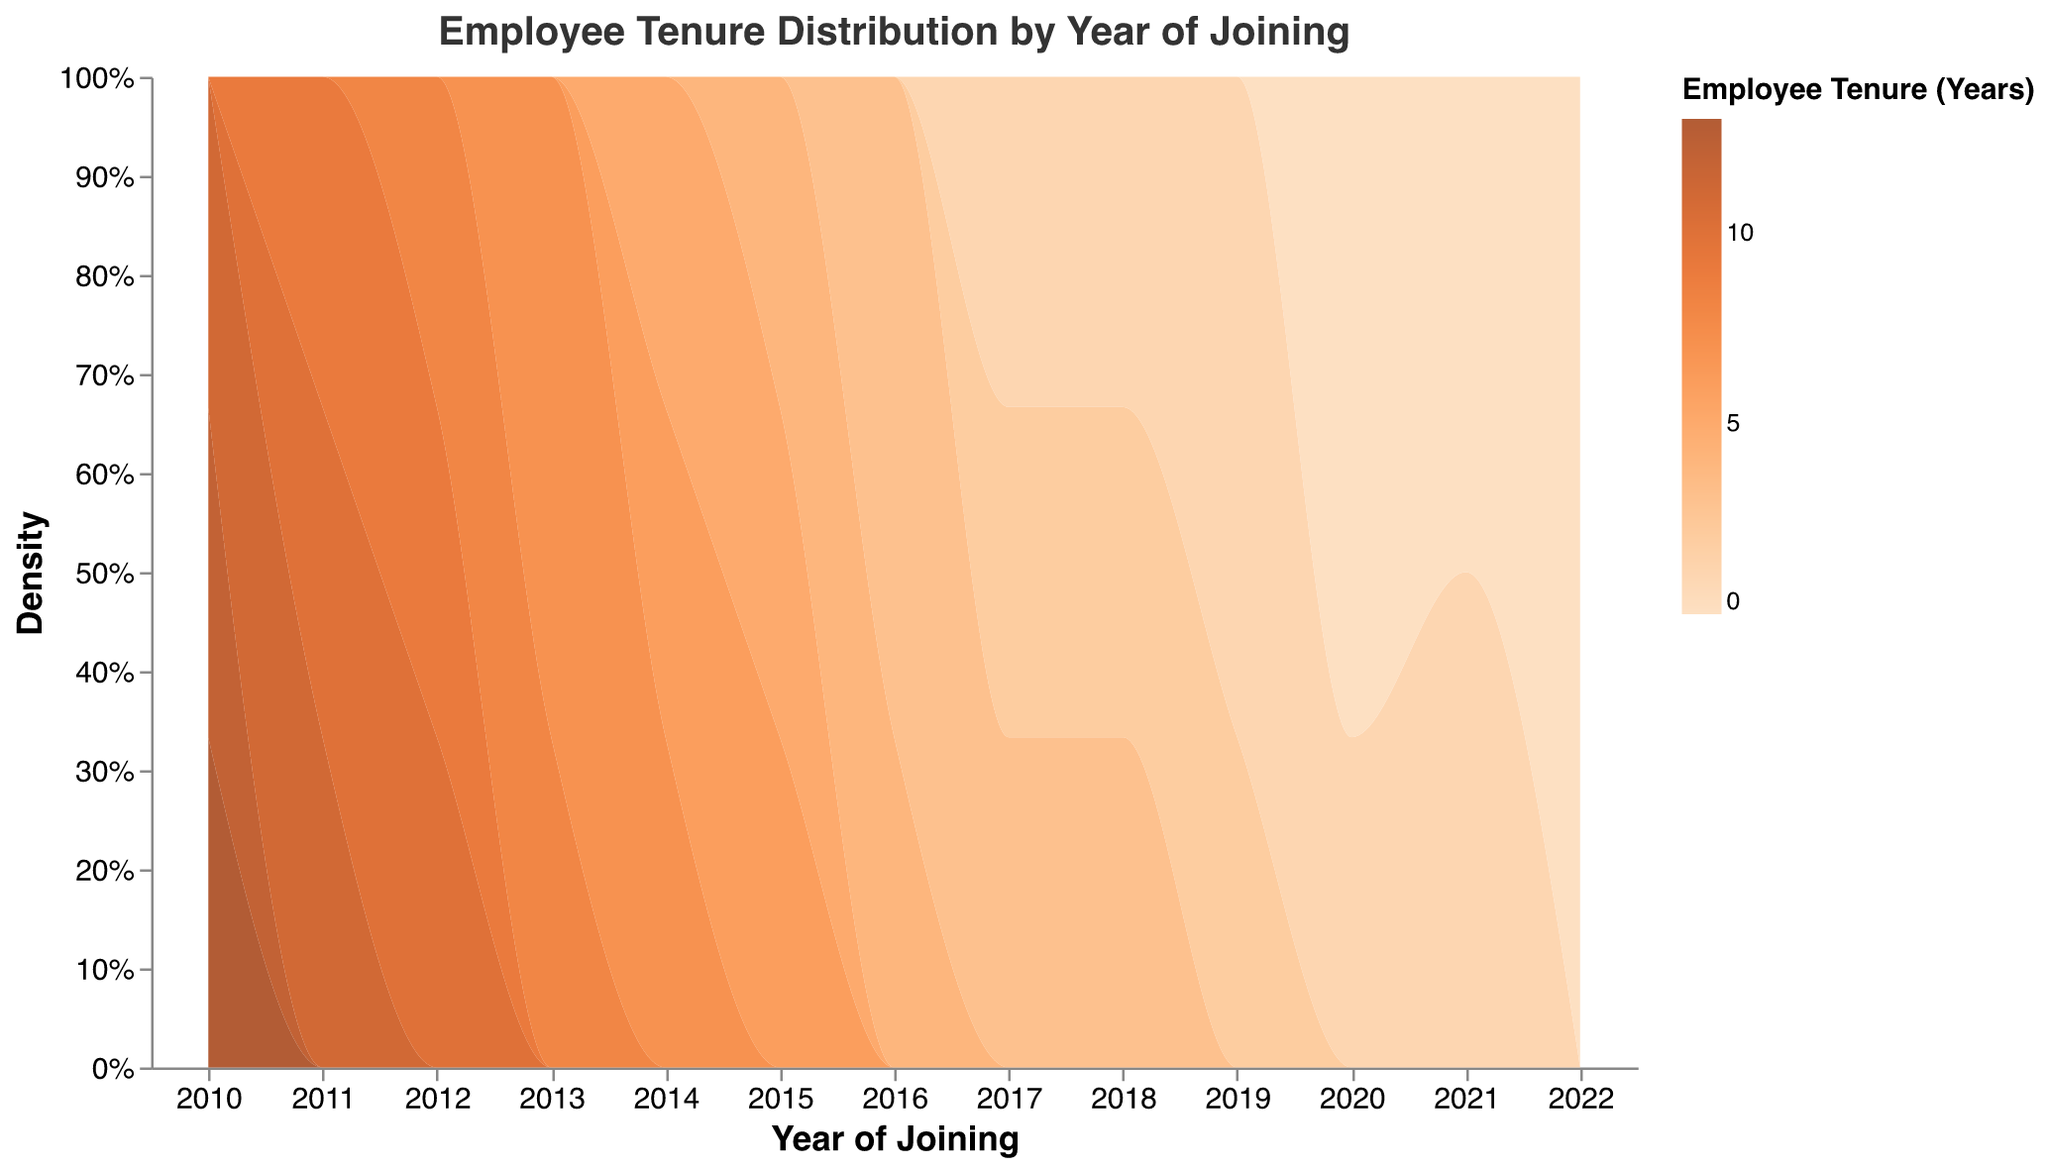What's the title of the plot? The title of the plot is typically located at the top of the chart and summarizes the theme of the figure. In this plot, the title is "Employee Tenure Distribution by Year of Joining."
Answer: Employee Tenure Distribution by Year of Joining What color scheme is used in the plot? The plot uses a gradient color scheme for the density area, ranging from a lighter to a darker orange. Central colors are #FFA07A (light orange) and #FF6347 (dark orange).
Answer: Orange gradient What does the Y-axis represent? The Y-axis in a density plot often represents the density or distribution of data points within a particular group. Here, it shows the normalized density of employees by their tenure years.
Answer: Density What do the colors in the legend signify? The color legend represents the number of years of employee tenure. It ranges from lighter colors (shorter tenure) to darker colors (longer tenure).
Answer: Employee Tenure (Years) Which year had the largest number of employees with 3 years of tenure? By comparing the densities in the plot, the year with the highest density of employees with 3 years tenure can be identified. The year with the largest density for 3 years of tenure is 2016.
Answer: 2016 How has the distribution of employee tenure changed from 2010 to 2022? Observing the density distributions, in 2010, most employees have higher tenure (11-13 years), while it gradually shifts to shorter tenures (0-2 years) in recent years (2020-2022). Longer tenures become less frequent over time.
Answer: Shifted from longer to shorter Which year had the broadest range of employee tenures? The year with the largest span of different tenures indicates a broader range. In 2010, employees' tenure ranged from 11 to 13 years, showing a narrower range compared to other years like, 2011, which had tenures from 9 to 11 years.
Answer: 2011 Between 2010 and 2015, which year had the smallest average employee tenure? To find this, calculate the average tenure for each year from 2010 to 2015 by summing the tenures and dividing by the number of employees for each year. Observing the density plot, 2014 and 2015 have lower tenures, likely with 2015 being the smallest.
Answer: 2015 Are there any years where the distribution of employee tenure is bimodal? Bimodal distribution indicates two peaks in the density curve. By reviewing the plot, employees in 2020, for example, mostly have tenures of 0 to 1 years, showing a single peak. No significant bimodal distribution observed.
Answer: No How does the employee tenure trend in the last two years, 2021 and 2022? The density plot shows a trend, with both 2021 and 2022 having a high density for 0-year tenures, indicating recent hires with minimal tenure.
Answer: Shorter tenure 